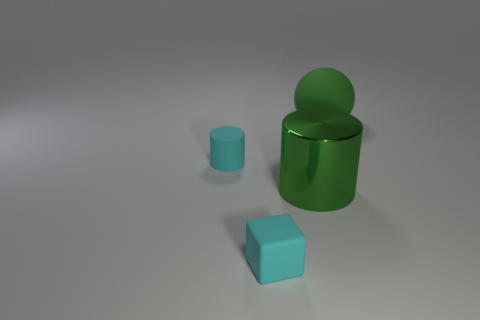There is another cyan object that is the same shape as the big shiny thing; what size is it?
Your answer should be compact. Small. What number of green cylinders have the same material as the cyan block?
Keep it short and to the point. 0. There is a small cyan rubber object in front of the large cylinder; what number of rubber objects are behind it?
Your response must be concise. 2. There is a small cyan cylinder; are there any cylinders behind it?
Provide a succinct answer. No. There is a object that is left of the cyan block; is it the same shape as the shiny thing?
Offer a very short reply. Yes. What material is the thing that is the same color as the big ball?
Ensure brevity in your answer.  Metal. How many large rubber balls are the same color as the tiny matte cylinder?
Offer a very short reply. 0. What is the shape of the big green thing that is in front of the large object that is behind the tiny cyan cylinder?
Offer a very short reply. Cylinder. Are there any other large green matte objects of the same shape as the large rubber object?
Give a very brief answer. No. There is a small matte cylinder; is it the same color as the small rubber object in front of the cyan cylinder?
Offer a very short reply. Yes. 